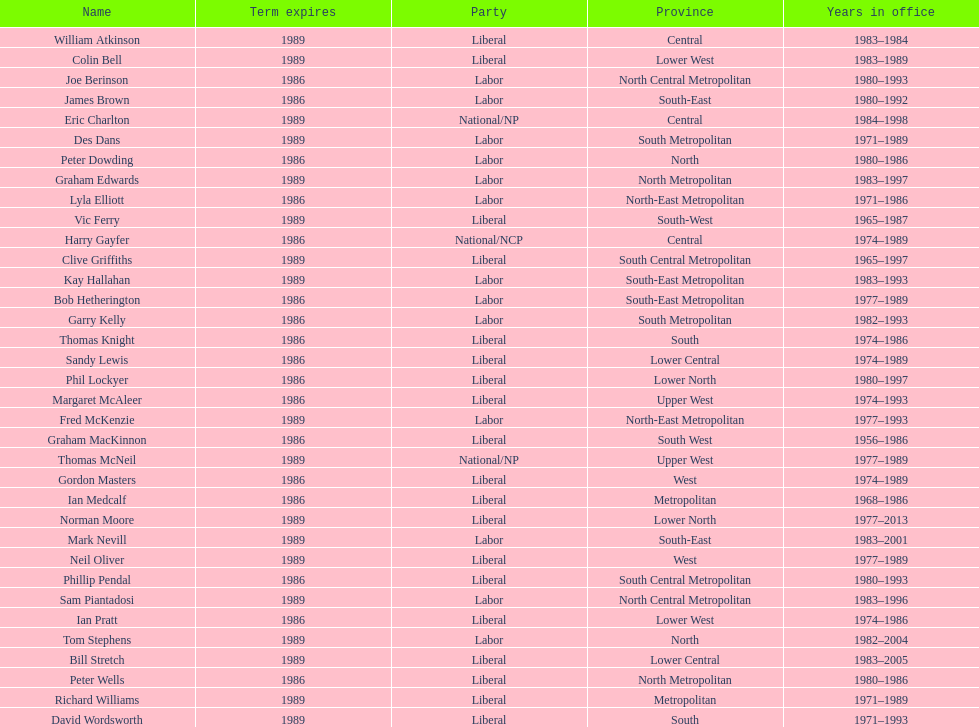What was phil lockyer's party? Liberal. 